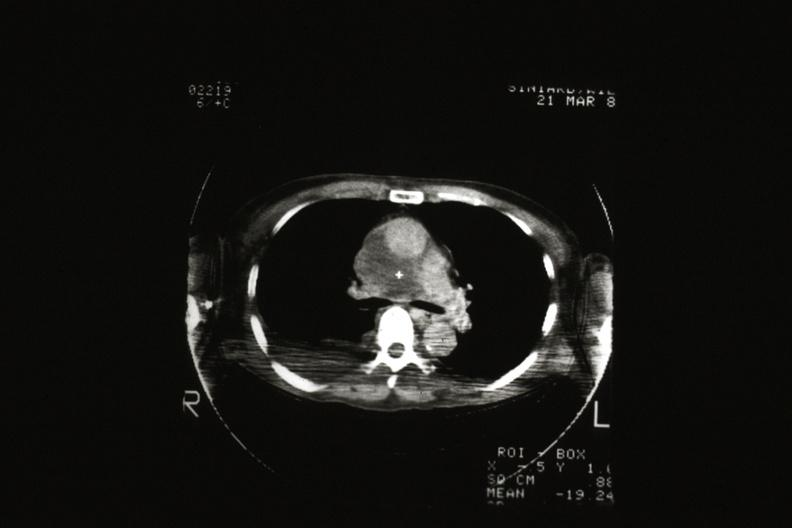what does this image show?
Answer the question using a single word or phrase. Cat scan showing tumor invading superior vena ca 